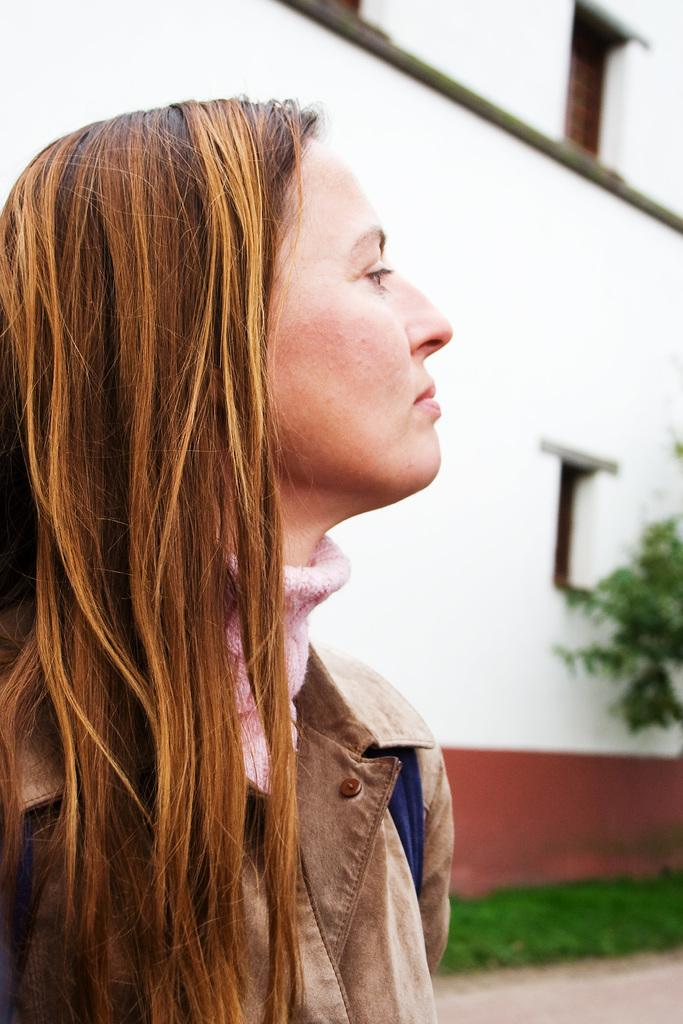Who is present in the image? There is a woman in the image. Where is the woman located? The woman is on a path. What can be seen behind the woman? There is a tree, grass, and a building behind the woman. What type of hat is the woman wearing in the image? There is no hat visible in the image. 